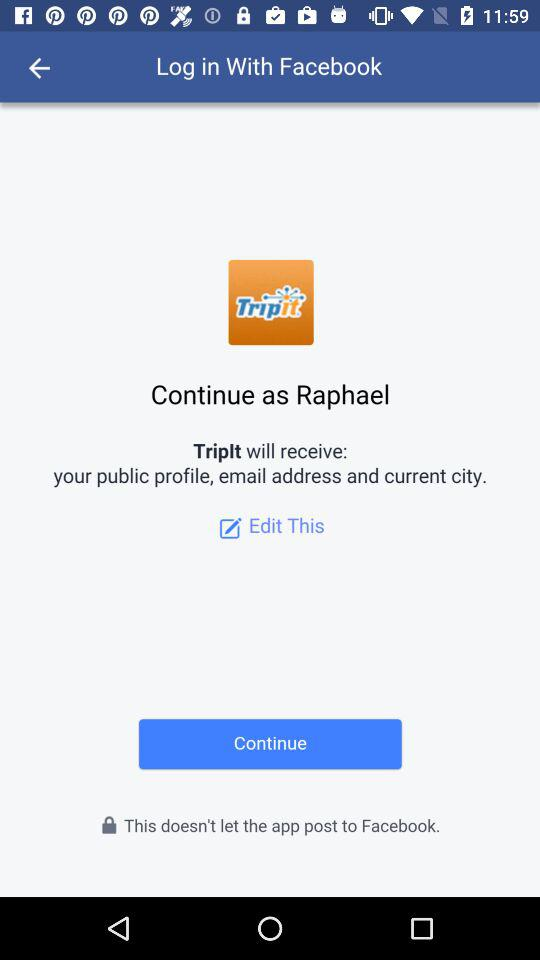What application is asking for permission? The application asking for permission is "TripIt". 